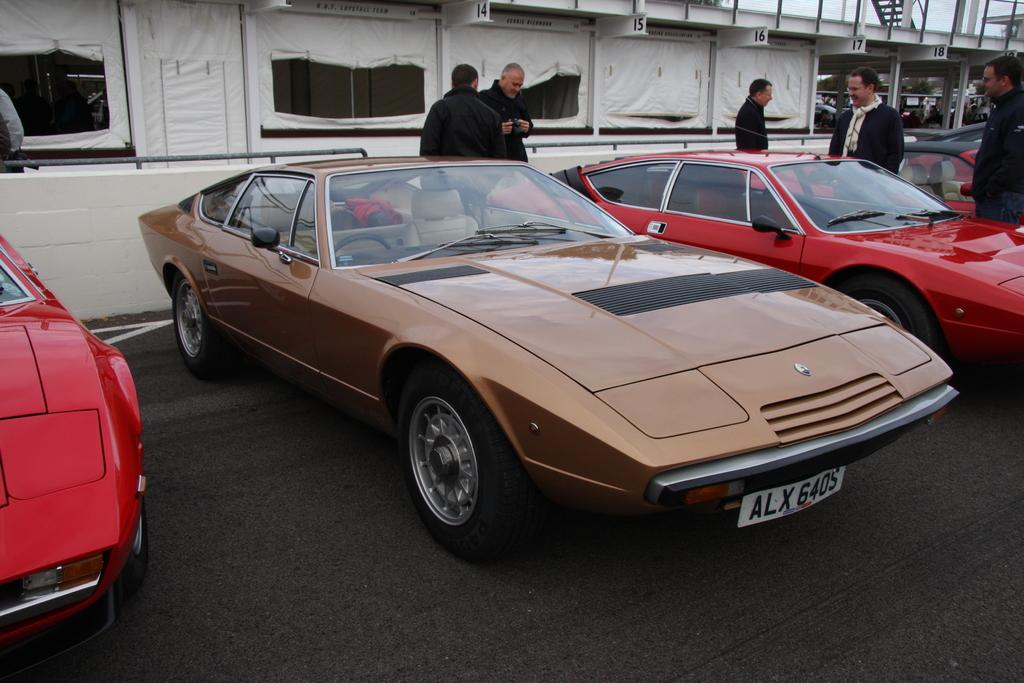Who or what is present in the image? There are people in the image. What can be seen on the road in the image? There are cars on the road in the image. What structures are visible in the background of the image? There are sheds in the background of the image. Where is the basin located in the image? There is no basin present in the image. What event is taking place in the image that led to the need for the people to gather? The image does not provide information about any specific event or need that brought the people together. 